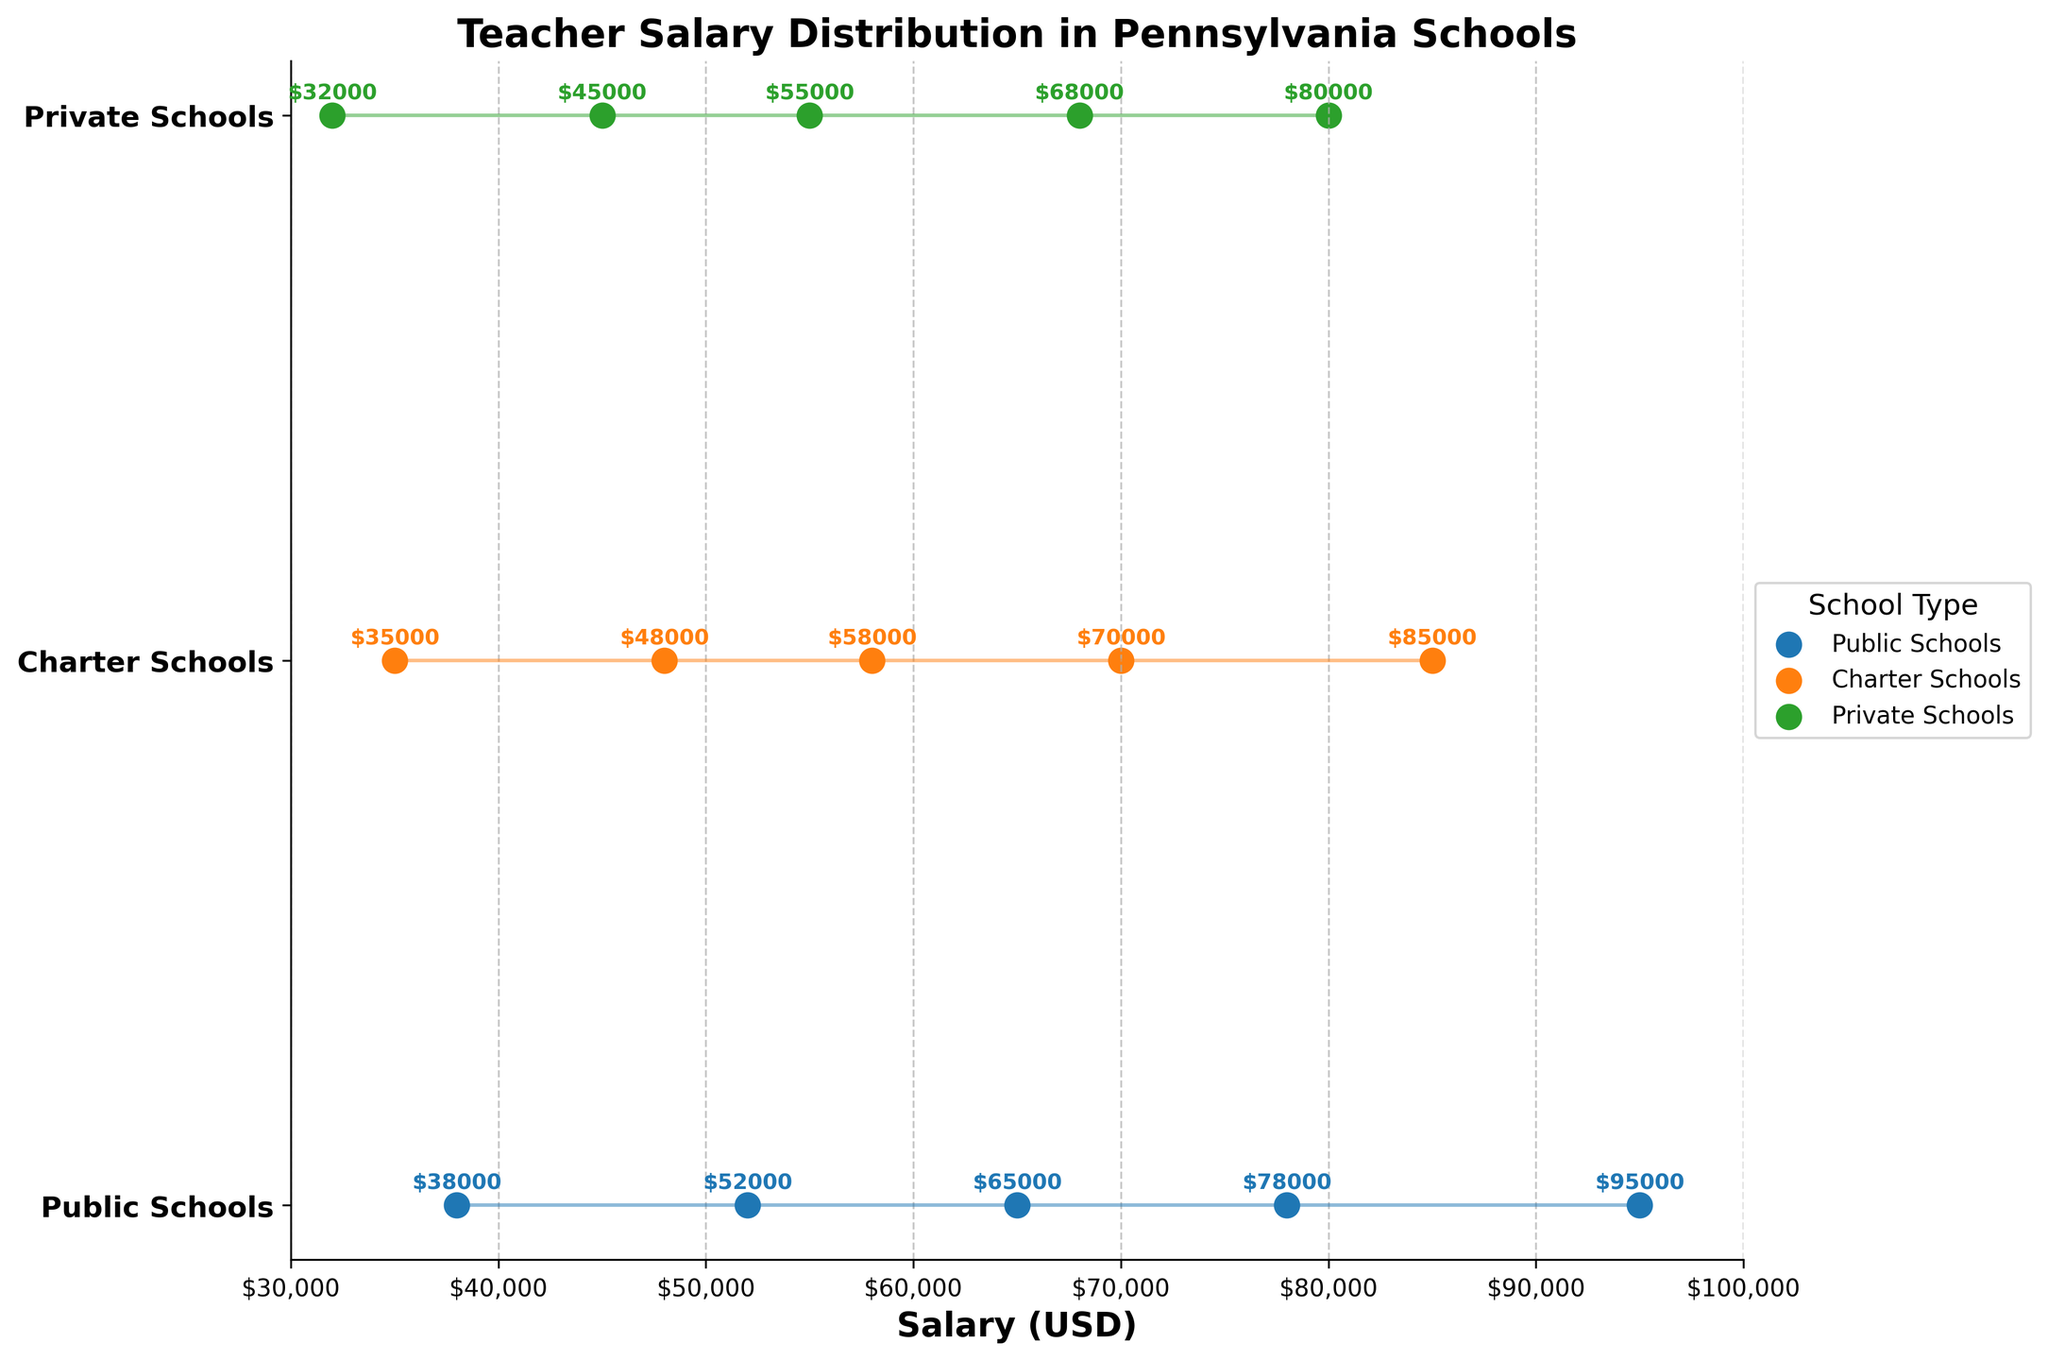What's the title of the figure? The title is typically located at the top of the figure. In this figure, it reads "Teacher Salary Distribution in Pennsylvania Schools."
Answer: Teacher Salary Distribution in Pennsylvania Schools What is the school type with the highest median salary? The median salary position is the third data point for each school type. By comparing these, Public Schools have a median salary of $65,000, which is higher than Charter Schools ($58,000) and Private Schools ($55,000).
Answer: Public Schools What is the range of salaries in Charter Schools? The range is calculated by subtracting the minimum salary from the maximum salary. For Charter Schools: $85,000 - $35,000 = $50,000.
Answer: $50,000 Which school type has the lowest maximum salary? Reviewing the maximum salary (rightmost data point) for each school type, Private Schools have the lowest maximum salary at $80,000.
Answer: Private Schools Compare the median salaries of Public and Private Schools. Which is higher and by how much? The median salary for Public Schools is $65,000, and for Private Schools, it is $55,000. The difference is $65,000 - $55,000 = $10,000. Public Schools have a higher median salary by $10,000.
Answer: Public Schools by $10,000 What's the average 25th percentile salary across all school types? First, note the 25th percentile salaries: Public Schools ($52,000), Charter Schools ($48,000), Private Schools ($45,000). The average is calculated as ($52,000 + $48,000 + $45,000)/3 = $145,000/3 ≈ $48,333.
Answer: $48,333 Which school type has the smallest interquartile range (IQR)? The IQR is calculated by subtracting the 25th percentile salary from the 75th percentile salary for each school type. Public Schools: $78,000 - $52,000 = $26,000; Charter Schools: $70,000 - $48,000 = $22,000; Private Schools: $68,000 - $45,000 = $23,000. Charter Schools have the smallest IQR.
Answer: Charter Schools What is the difference between the maximum salary of Public Schools and the minimum salary of Private Schools? The maximum salary for Public Schools is $95,000, and the minimum salary for Private Schools is $32,000. The difference is $95,000 - $32,000 = $63,000.
Answer: $63,000 Describe how the salaries in Private Schools are distributed compared to Public and Charter Schools. Evaluating the spread, Private Schools have the lowest minimum and maximum salaries. The data points indicate narrower salary ranges overall, with the salaries clustering lower than those of Public and Charter Schools.
Answer: Narrower and lower distributed What are the colors representing each school type in the figure? By observing the color scheme of the scatter plots and the legend, three different colors are used: Public Schools (blue), Charter Schools (orange), Private Schools (green).
Answer: Public Schools (blue), Charter Schools (orange), Private Schools (green) 